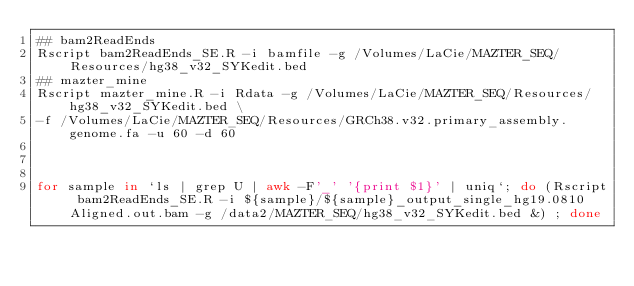<code> <loc_0><loc_0><loc_500><loc_500><_Bash_>## bam2ReadEnds
Rscript bam2ReadEnds_SE.R -i bamfile -g /Volumes/LaCie/MAZTER_SEQ/Resources/hg38_v32_SYKedit.bed
## mazter_mine
Rscript mazter_mine.R -i Rdata -g /Volumes/LaCie/MAZTER_SEQ/Resources/hg38_v32_SYKedit.bed \
-f /Volumes/LaCie/MAZTER_SEQ/Resources/GRCh38.v32.primary_assembly.genome.fa -u 60 -d 60



for sample in `ls | grep U | awk -F'_' '{print $1}' | uniq`; do (Rscript bam2ReadEnds_SE.R -i ${sample}/${sample}_output_single_hg19.0810Aligned.out.bam -g /data2/MAZTER_SEQ/hg38_v32_SYKedit.bed &) ; done</code> 